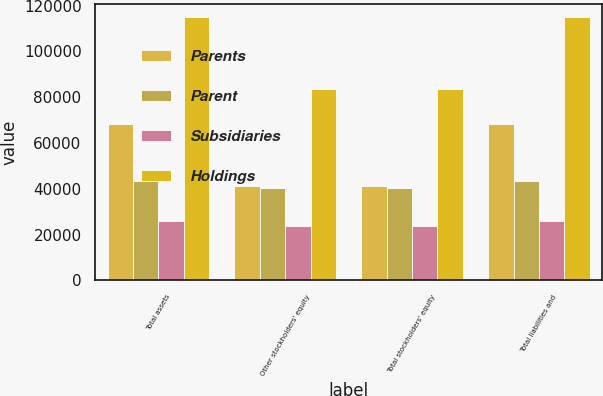<chart> <loc_0><loc_0><loc_500><loc_500><stacked_bar_chart><ecel><fcel>Total assets<fcel>Other stockholders' equity<fcel>Total stockholders' equity<fcel>Total liabilities and<nl><fcel>Parents<fcel>68492<fcel>41306<fcel>41340<fcel>68492<nl><fcel>Parent<fcel>43356<fcel>40240<fcel>40240<fcel>43356<nl><fcel>Subsidiaries<fcel>25845<fcel>23732<fcel>23732<fcel>25845<nl><fcel>Holdings<fcel>115014<fcel>83603<fcel>83603<fcel>115014<nl></chart> 